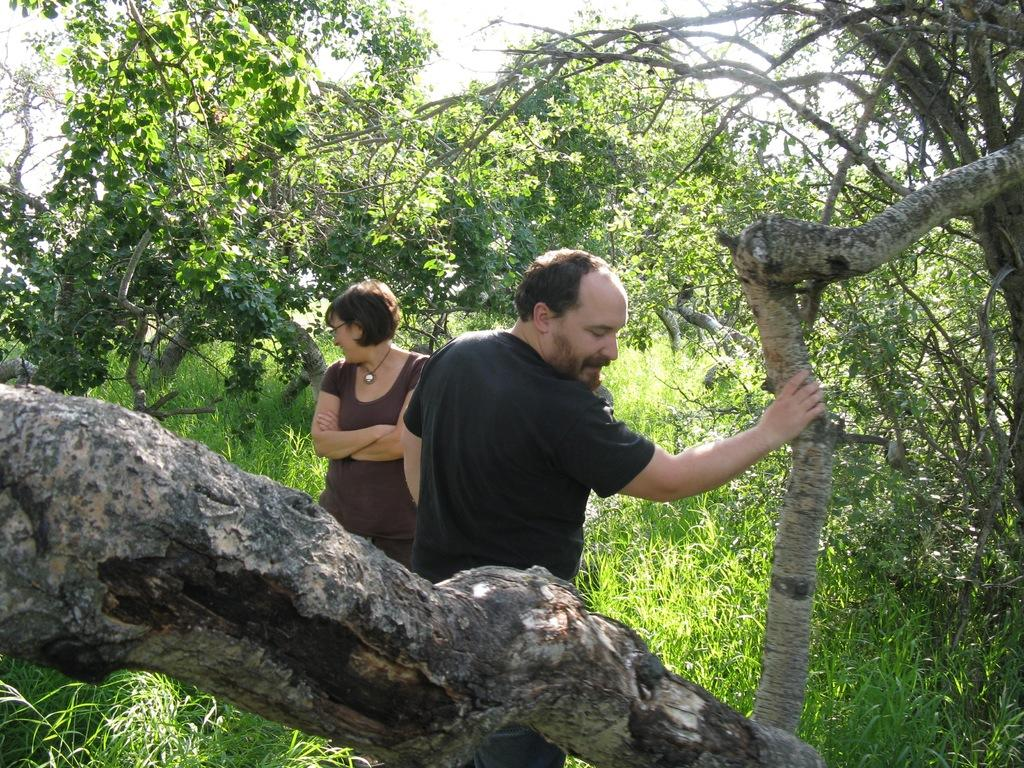How many people are present in the image? There are two persons standing in the image. What type of vegetation can be seen in the image? There are trees and grass in the image. What is visible in the background of the image? The sky is visible in the background of the image. How many waves can be seen crashing on the shore in the image? There is no shore or waves present in the image; it features two persons standing in a natural environment with trees, grass, and a visible sky. 